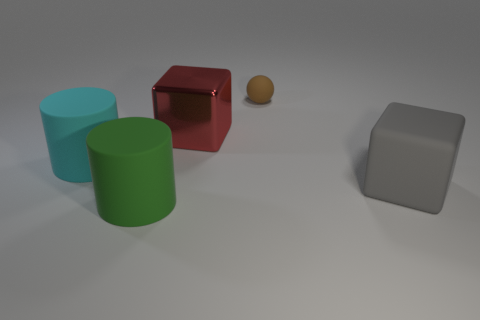Is there any other thing that is the same shape as the brown object?
Provide a short and direct response. No. What number of other objects are there of the same size as the red cube?
Your answer should be compact. 3. There is a object that is in front of the cyan rubber cylinder and on the left side of the small rubber thing; what is its material?
Offer a very short reply. Rubber. There is a matte thing that is both to the left of the red metal thing and right of the big cyan thing; what is its shape?
Your response must be concise. Cylinder. There is a brown rubber thing; does it have the same size as the cylinder behind the big gray rubber thing?
Ensure brevity in your answer.  No. The other large matte thing that is the same shape as the big green rubber object is what color?
Provide a short and direct response. Cyan. There is a thing that is to the right of the tiny brown matte thing; does it have the same size as the rubber cylinder on the right side of the cyan cylinder?
Keep it short and to the point. Yes. Is the shape of the large cyan rubber object the same as the big green rubber thing?
Make the answer very short. Yes. What number of things are big rubber cylinders to the left of the green cylinder or large cyan cubes?
Provide a succinct answer. 1. Is there a big red shiny object of the same shape as the green matte thing?
Offer a very short reply. No. 